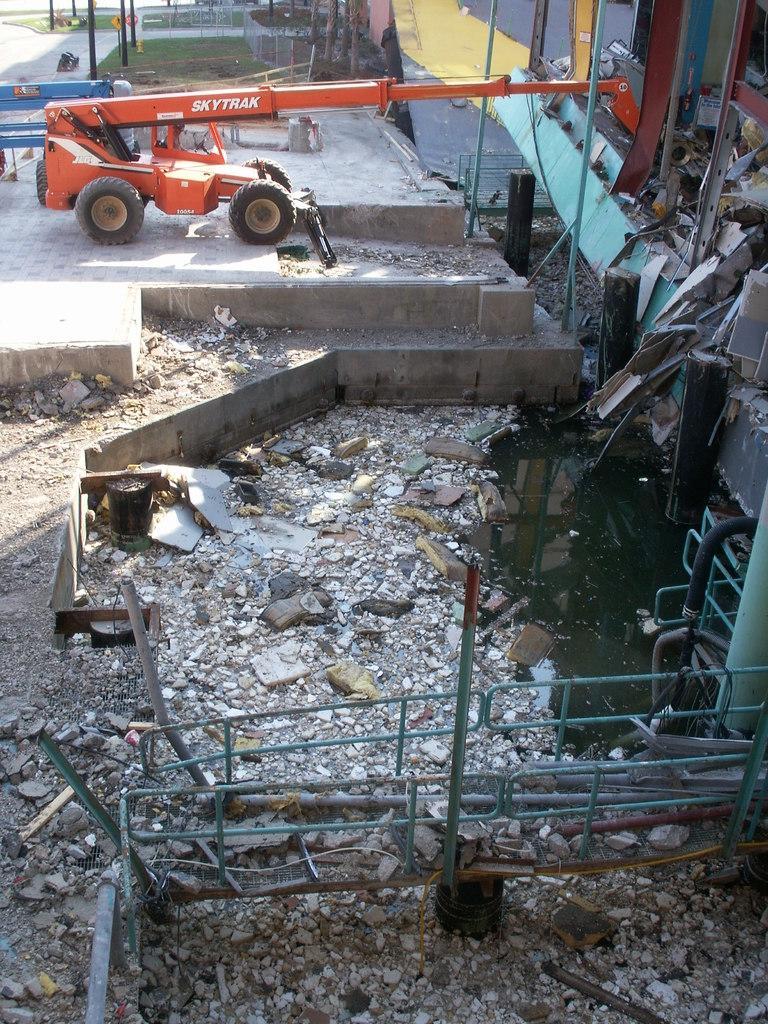Describe this image in one or two sentences. In this picture we can see a vehicle on the ground, stones, rods, grass and in the background we can see poles. 